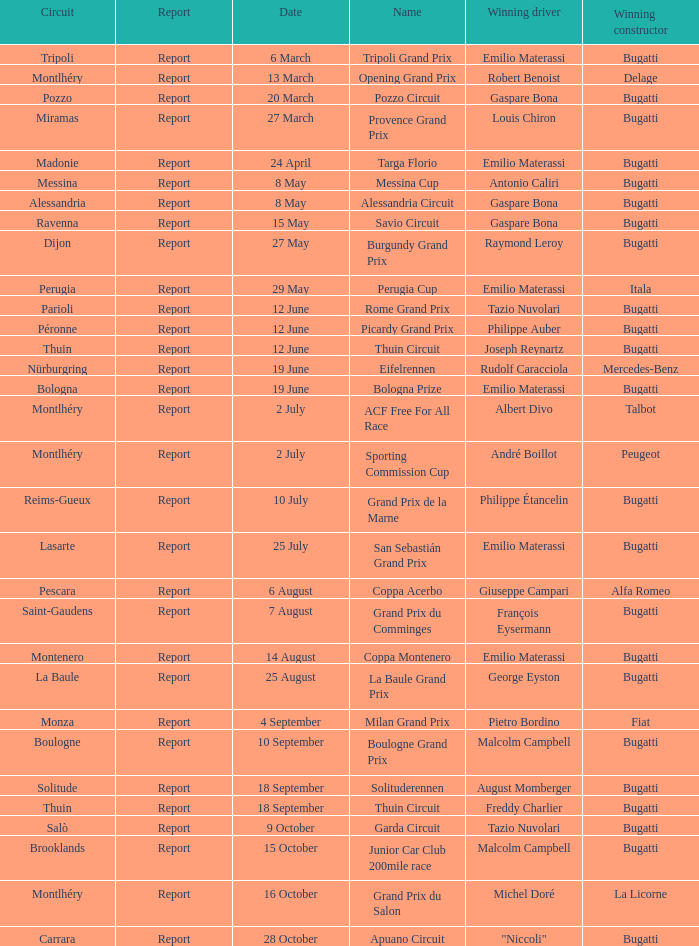Who was the winning constructor of the Grand Prix Du Salon ? La Licorne. Could you help me parse every detail presented in this table? {'header': ['Circuit', 'Report', 'Date', 'Name', 'Winning driver', 'Winning constructor'], 'rows': [['Tripoli', 'Report', '6 March', 'Tripoli Grand Prix', 'Emilio Materassi', 'Bugatti'], ['Montlhéry', 'Report', '13 March', 'Opening Grand Prix', 'Robert Benoist', 'Delage'], ['Pozzo', 'Report', '20 March', 'Pozzo Circuit', 'Gaspare Bona', 'Bugatti'], ['Miramas', 'Report', '27 March', 'Provence Grand Prix', 'Louis Chiron', 'Bugatti'], ['Madonie', 'Report', '24 April', 'Targa Florio', 'Emilio Materassi', 'Bugatti'], ['Messina', 'Report', '8 May', 'Messina Cup', 'Antonio Caliri', 'Bugatti'], ['Alessandria', 'Report', '8 May', 'Alessandria Circuit', 'Gaspare Bona', 'Bugatti'], ['Ravenna', 'Report', '15 May', 'Savio Circuit', 'Gaspare Bona', 'Bugatti'], ['Dijon', 'Report', '27 May', 'Burgundy Grand Prix', 'Raymond Leroy', 'Bugatti'], ['Perugia', 'Report', '29 May', 'Perugia Cup', 'Emilio Materassi', 'Itala'], ['Parioli', 'Report', '12 June', 'Rome Grand Prix', 'Tazio Nuvolari', 'Bugatti'], ['Péronne', 'Report', '12 June', 'Picardy Grand Prix', 'Philippe Auber', 'Bugatti'], ['Thuin', 'Report', '12 June', 'Thuin Circuit', 'Joseph Reynartz', 'Bugatti'], ['Nürburgring', 'Report', '19 June', 'Eifelrennen', 'Rudolf Caracciola', 'Mercedes-Benz'], ['Bologna', 'Report', '19 June', 'Bologna Prize', 'Emilio Materassi', 'Bugatti'], ['Montlhéry', 'Report', '2 July', 'ACF Free For All Race', 'Albert Divo', 'Talbot'], ['Montlhéry', 'Report', '2 July', 'Sporting Commission Cup', 'André Boillot', 'Peugeot'], ['Reims-Gueux', 'Report', '10 July', 'Grand Prix de la Marne', 'Philippe Étancelin', 'Bugatti'], ['Lasarte', 'Report', '25 July', 'San Sebastián Grand Prix', 'Emilio Materassi', 'Bugatti'], ['Pescara', 'Report', '6 August', 'Coppa Acerbo', 'Giuseppe Campari', 'Alfa Romeo'], ['Saint-Gaudens', 'Report', '7 August', 'Grand Prix du Comminges', 'François Eysermann', 'Bugatti'], ['Montenero', 'Report', '14 August', 'Coppa Montenero', 'Emilio Materassi', 'Bugatti'], ['La Baule', 'Report', '25 August', 'La Baule Grand Prix', 'George Eyston', 'Bugatti'], ['Monza', 'Report', '4 September', 'Milan Grand Prix', 'Pietro Bordino', 'Fiat'], ['Boulogne', 'Report', '10 September', 'Boulogne Grand Prix', 'Malcolm Campbell', 'Bugatti'], ['Solitude', 'Report', '18 September', 'Solituderennen', 'August Momberger', 'Bugatti'], ['Thuin', 'Report', '18 September', 'Thuin Circuit', 'Freddy Charlier', 'Bugatti'], ['Salò', 'Report', '9 October', 'Garda Circuit', 'Tazio Nuvolari', 'Bugatti'], ['Brooklands', 'Report', '15 October', 'Junior Car Club 200mile race', 'Malcolm Campbell', 'Bugatti'], ['Montlhéry', 'Report', '16 October', 'Grand Prix du Salon', 'Michel Doré', 'La Licorne'], ['Carrara', 'Report', '28 October', 'Apuano Circuit', '"Niccoli"', 'Bugatti']]} 